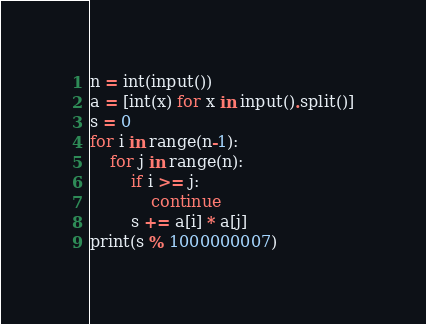<code> <loc_0><loc_0><loc_500><loc_500><_Python_>n = int(input())
a = [int(x) for x in input().split()]
s = 0
for i in range(n-1):
    for j in range(n):
        if i >= j:
            continue
        s += a[i] * a[j]
print(s % 1000000007)</code> 